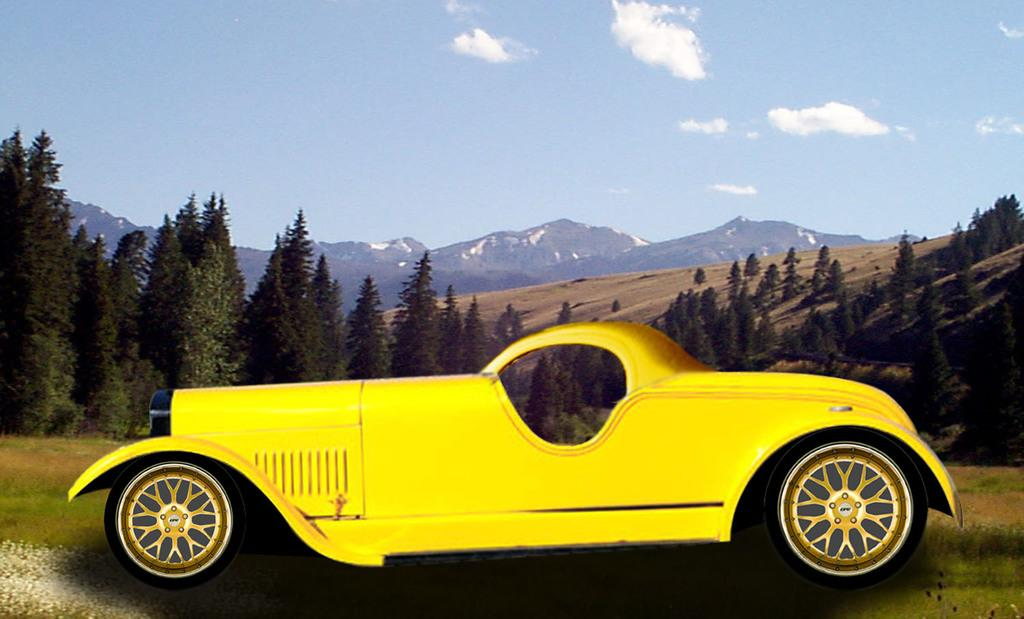What type of natural landscape is depicted in the image? The image features many mountains. How would you describe the sky in the image? The sky is blue and slightly cloudy in the image. What other natural elements can be seen in the image? There are many trees in the image. What is the animated object in the image? There is an animated car in the image. What month is it in the image? The month cannot be determined from the image, as it does not contain any information about the time of year. 